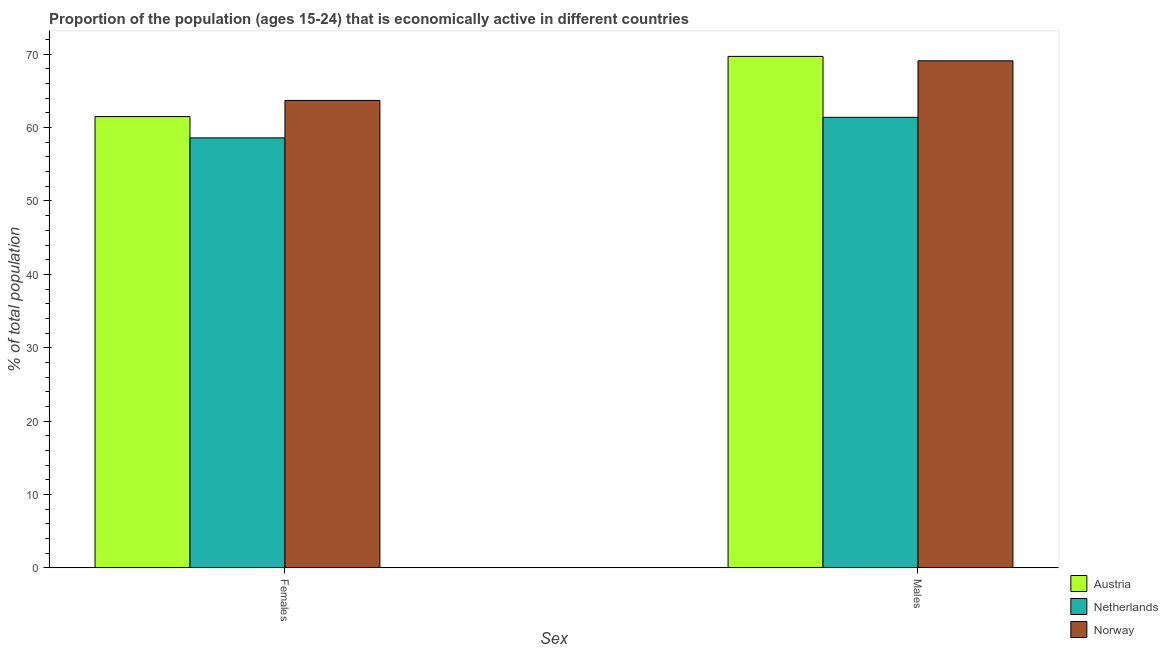How many different coloured bars are there?
Provide a short and direct response. 3. How many groups of bars are there?
Provide a short and direct response. 2. How many bars are there on the 1st tick from the left?
Offer a terse response. 3. What is the label of the 2nd group of bars from the left?
Offer a very short reply. Males. What is the percentage of economically active male population in Norway?
Provide a succinct answer. 69.1. Across all countries, what is the maximum percentage of economically active male population?
Make the answer very short. 69.7. Across all countries, what is the minimum percentage of economically active male population?
Keep it short and to the point. 61.4. In which country was the percentage of economically active male population maximum?
Make the answer very short. Austria. What is the total percentage of economically active male population in the graph?
Offer a very short reply. 200.2. What is the difference between the percentage of economically active female population in Norway and that in Austria?
Provide a short and direct response. 2.2. What is the difference between the percentage of economically active male population in Netherlands and the percentage of economically active female population in Austria?
Make the answer very short. -0.1. What is the average percentage of economically active female population per country?
Offer a terse response. 61.27. What is the difference between the percentage of economically active male population and percentage of economically active female population in Austria?
Your response must be concise. 8.2. What is the ratio of the percentage of economically active female population in Norway to that in Austria?
Your response must be concise. 1.04. Is the percentage of economically active female population in Netherlands less than that in Austria?
Your answer should be compact. Yes. How many bars are there?
Provide a succinct answer. 6. How many countries are there in the graph?
Ensure brevity in your answer.  3. What is the difference between two consecutive major ticks on the Y-axis?
Your answer should be very brief. 10. Are the values on the major ticks of Y-axis written in scientific E-notation?
Ensure brevity in your answer.  No. How many legend labels are there?
Ensure brevity in your answer.  3. How are the legend labels stacked?
Your response must be concise. Vertical. What is the title of the graph?
Your answer should be compact. Proportion of the population (ages 15-24) that is economically active in different countries. What is the label or title of the X-axis?
Ensure brevity in your answer.  Sex. What is the label or title of the Y-axis?
Provide a short and direct response. % of total population. What is the % of total population in Austria in Females?
Your answer should be compact. 61.5. What is the % of total population of Netherlands in Females?
Provide a short and direct response. 58.6. What is the % of total population of Norway in Females?
Keep it short and to the point. 63.7. What is the % of total population of Austria in Males?
Give a very brief answer. 69.7. What is the % of total population of Netherlands in Males?
Your answer should be very brief. 61.4. What is the % of total population in Norway in Males?
Keep it short and to the point. 69.1. Across all Sex, what is the maximum % of total population of Austria?
Your answer should be very brief. 69.7. Across all Sex, what is the maximum % of total population in Netherlands?
Provide a succinct answer. 61.4. Across all Sex, what is the maximum % of total population in Norway?
Offer a very short reply. 69.1. Across all Sex, what is the minimum % of total population in Austria?
Your response must be concise. 61.5. Across all Sex, what is the minimum % of total population in Netherlands?
Your answer should be compact. 58.6. Across all Sex, what is the minimum % of total population in Norway?
Provide a succinct answer. 63.7. What is the total % of total population of Austria in the graph?
Provide a short and direct response. 131.2. What is the total % of total population of Netherlands in the graph?
Provide a short and direct response. 120. What is the total % of total population of Norway in the graph?
Ensure brevity in your answer.  132.8. What is the difference between the % of total population in Netherlands in Females and that in Males?
Your response must be concise. -2.8. What is the difference between the % of total population in Netherlands in Females and the % of total population in Norway in Males?
Your answer should be compact. -10.5. What is the average % of total population of Austria per Sex?
Provide a short and direct response. 65.6. What is the average % of total population in Norway per Sex?
Your answer should be compact. 66.4. What is the difference between the % of total population in Austria and % of total population in Netherlands in Females?
Offer a very short reply. 2.9. What is the difference between the % of total population of Austria and % of total population of Norway in Females?
Make the answer very short. -2.2. What is the difference between the % of total population in Netherlands and % of total population in Norway in Females?
Make the answer very short. -5.1. What is the difference between the % of total population of Netherlands and % of total population of Norway in Males?
Make the answer very short. -7.7. What is the ratio of the % of total population in Austria in Females to that in Males?
Make the answer very short. 0.88. What is the ratio of the % of total population of Netherlands in Females to that in Males?
Provide a short and direct response. 0.95. What is the ratio of the % of total population in Norway in Females to that in Males?
Provide a short and direct response. 0.92. What is the difference between the highest and the lowest % of total population in Austria?
Give a very brief answer. 8.2. 